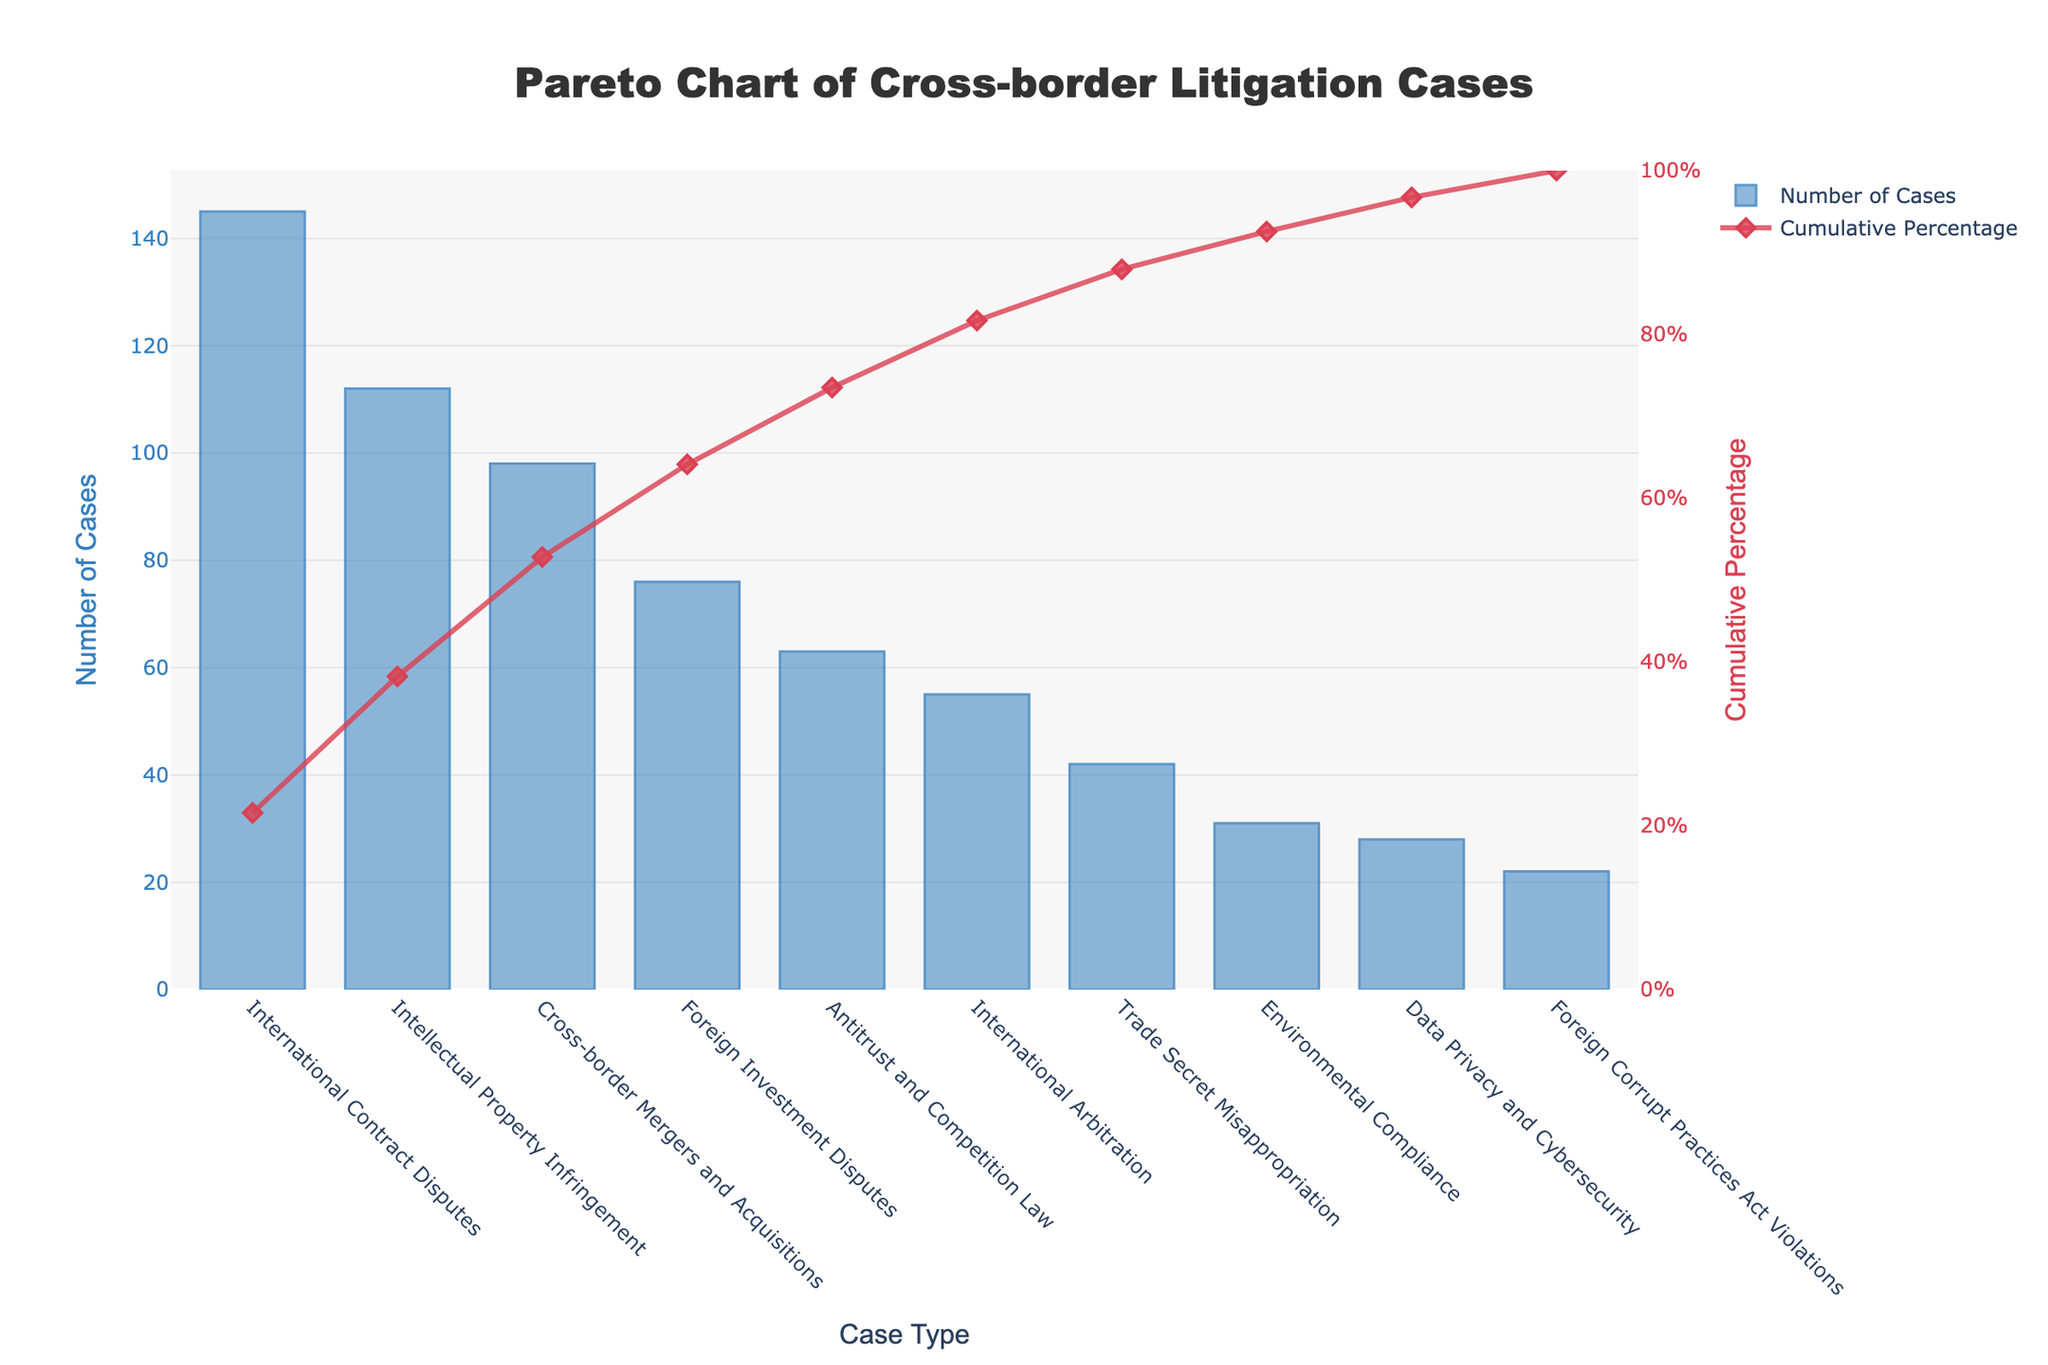What is the title of the chart? The title of the chart is displayed at the top center and reads "Pareto Chart of Cross-border Litigation Cases".
Answer: Pareto Chart of Cross-border Litigation Cases Which case type has the highest number of cases? The highest bar on the chart represents the case type with the most cases, which is "International Contract Disputes".
Answer: International Contract Disputes What is the cumulative percentage of the top three case types? To find the cumulative percentage of the top three case types, sum their number of cases: 145 (International Contract Disputes) + 112 (Intellectual Property Infringement) + 98 (Cross-border Mergers and Acquisitions) = 355 cases. Divide by the total number of cases (672) and multiply by 100 to get the cumulative percentage: 355/672 * 100 ≈ 52.8%.
Answer: 52.8% How does the number of Intellectual Property Infringement cases compare to Cross-border Mergers and Acquisitions cases? Compare the heights of the bars for "Intellectual Property Infringement" (112 cases) and "Cross-border Mergers and Acquisitions" (98 cases). 112 is greater than 98.
Answer: Intellectual Property Infringement cases are more common What percentage of the total cases do International Contract Disputes alone represent? Divide the number of "International Contract Disputes" cases (145) by the total number of cases (672) and multiply by 100 to get the percentage: 145/672 * 100 ≈ 21.6%.
Answer: 21.6% At what cumulative percentage do we reach after considering Foreign Investment Disputes? The cumulative percentage up to "Foreign Investment Disputes" can be found by summing the percentages up to this point, given on the y-axis on the right.
Answer: Approximately 64% What is the main insight provided by combining the bar and line elements in this Pareto chart? The bars show the frequency of each case type, while the cumulative percentage line reveals how these frequencies add up cumulatively, demonstrating the Pareto principle where a smaller number of case types often constitute a larger cumulative percentage. This helps in identifying that a few case types dominate the overall cases.
Answer: A few case types dominate the overall cases Which case type has the lowest number of cases, and what is its cumulative percentage? The shortest bar represents the case type with the fewest cases, which is "Foreign Corrupt Practices Act Violations" (22 cases). The cumulative percentage at this point on the y2-axis is approximately 100%.
Answer: Foreign Corrupt Practices Act Violations, approximately 100% How do Antitrust and Competition Law cases compare to International Arbitration cases in terms of their position and cumulative impact? Antitrust and Competition Law cases (63) appear before International Arbitration cases (55) on the x-axis and contribute more heavily to the cumulative percentage.
Answer: Antitrust and Competition Law cases contribute more and appear earlier What would be the impact on cumulative percentage if Trade Secret Misappropriation cases were doubled? Currently, Trade Secret Misappropriation cases are 42. If doubled, they become 84. Adding the additional 42 cases to the total (672 + 42 = 714), recalculate the cumulative percentage at that point: adding 42 cases increases the cumulative total at Trade Secret Misappropriation to  491. The new cumulative percentage = 491/714 * 100 ≈ 68.7%.
Answer: Approximately 68.7% 